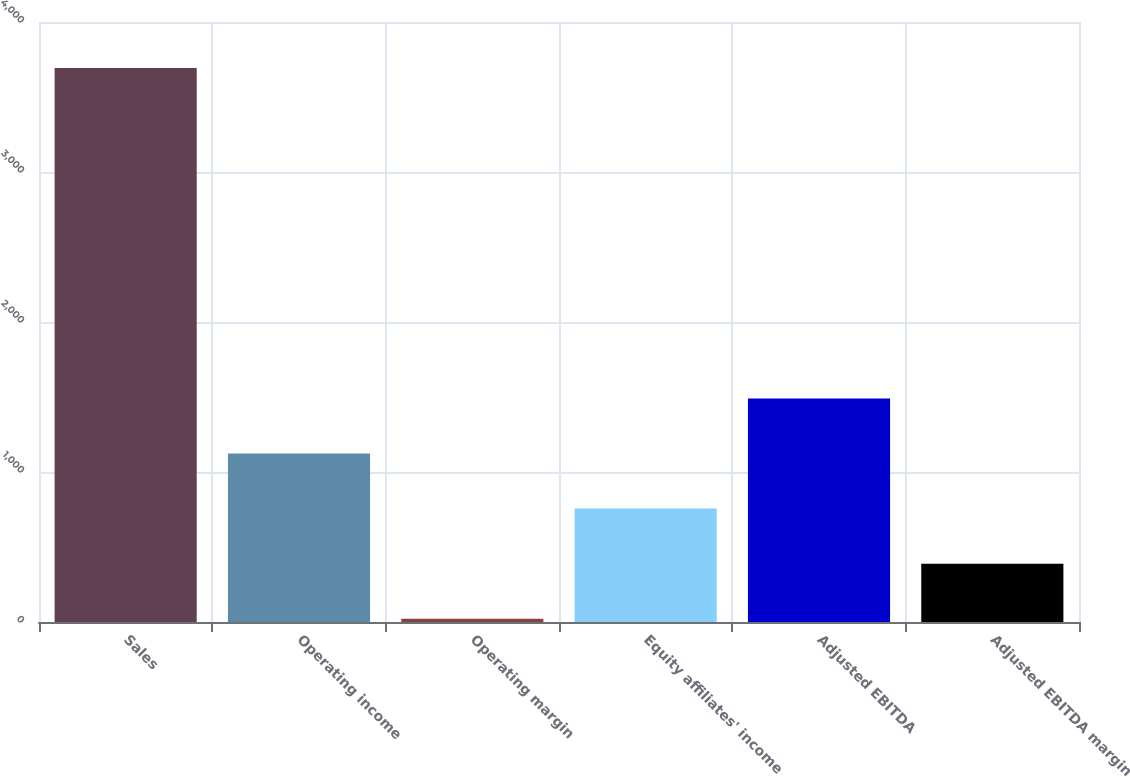Convert chart. <chart><loc_0><loc_0><loc_500><loc_500><bar_chart><fcel>Sales<fcel>Operating income<fcel>Operating margin<fcel>Equity affiliates' income<fcel>Adjusted EBITDA<fcel>Adjusted EBITDA margin<nl><fcel>3693.9<fcel>1123.5<fcel>21.9<fcel>756.3<fcel>1490.7<fcel>389.1<nl></chart> 